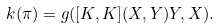Convert formula to latex. <formula><loc_0><loc_0><loc_500><loc_500>k ( \pi ) = g ( [ K , K ] ( X , Y ) Y , X ) .</formula> 